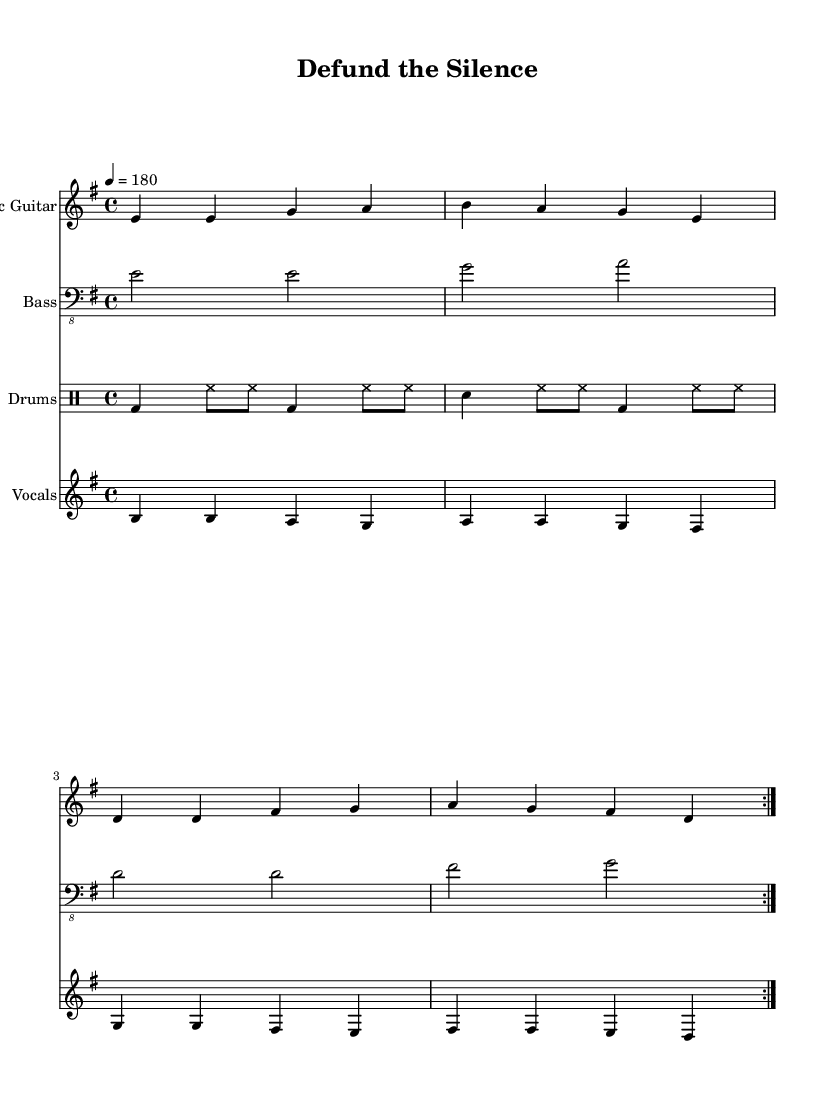What is the key signature of this music? The key signature is E minor, which has one sharp (F#).
Answer: E minor What is the time signature of this song? The time signature is 4/4, indicating four beats per measure.
Answer: 4/4 What is the tempo marking given in this music? The tempo is marked as quarter note equals 180 beats per minute.
Answer: 180 How many volta repetitions are indicated for the main sections? There are two volta repetitions indicated, which can be seen with the repeat signs.
Answer: 2 What phrase describes the main message in the lyrics? The lyrics convey a critique of government funding cuts to arts and culture.
Answer: Defund the silence What instrument plays the highest pitch in this piece? The electric guitar plays the highest pitches among the instruments listed.
Answer: Electric Guitar What is the primary theme of the chorus lyrics? The primary theme of the chorus emphasizes resistance through art and culture.
Answer: Art is our defiance 